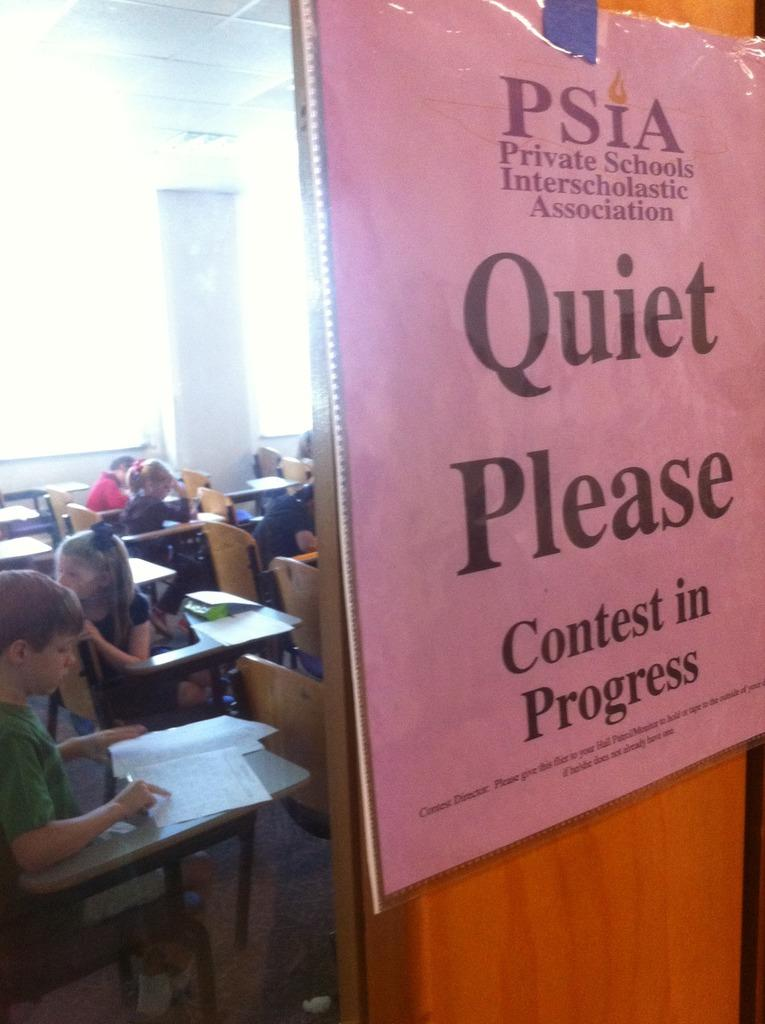<image>
Write a terse but informative summary of the picture. Kids fill out their test sheets behind a door which bears a notice saying quiet please, contest in progress. 